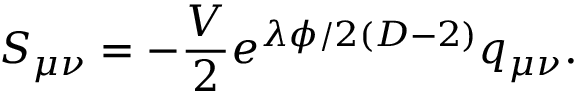<formula> <loc_0><loc_0><loc_500><loc_500>S _ { \mu \nu } = - \frac { V } { 2 } e ^ { \lambda \phi / 2 ( D - 2 ) } q _ { \mu \nu } .</formula> 